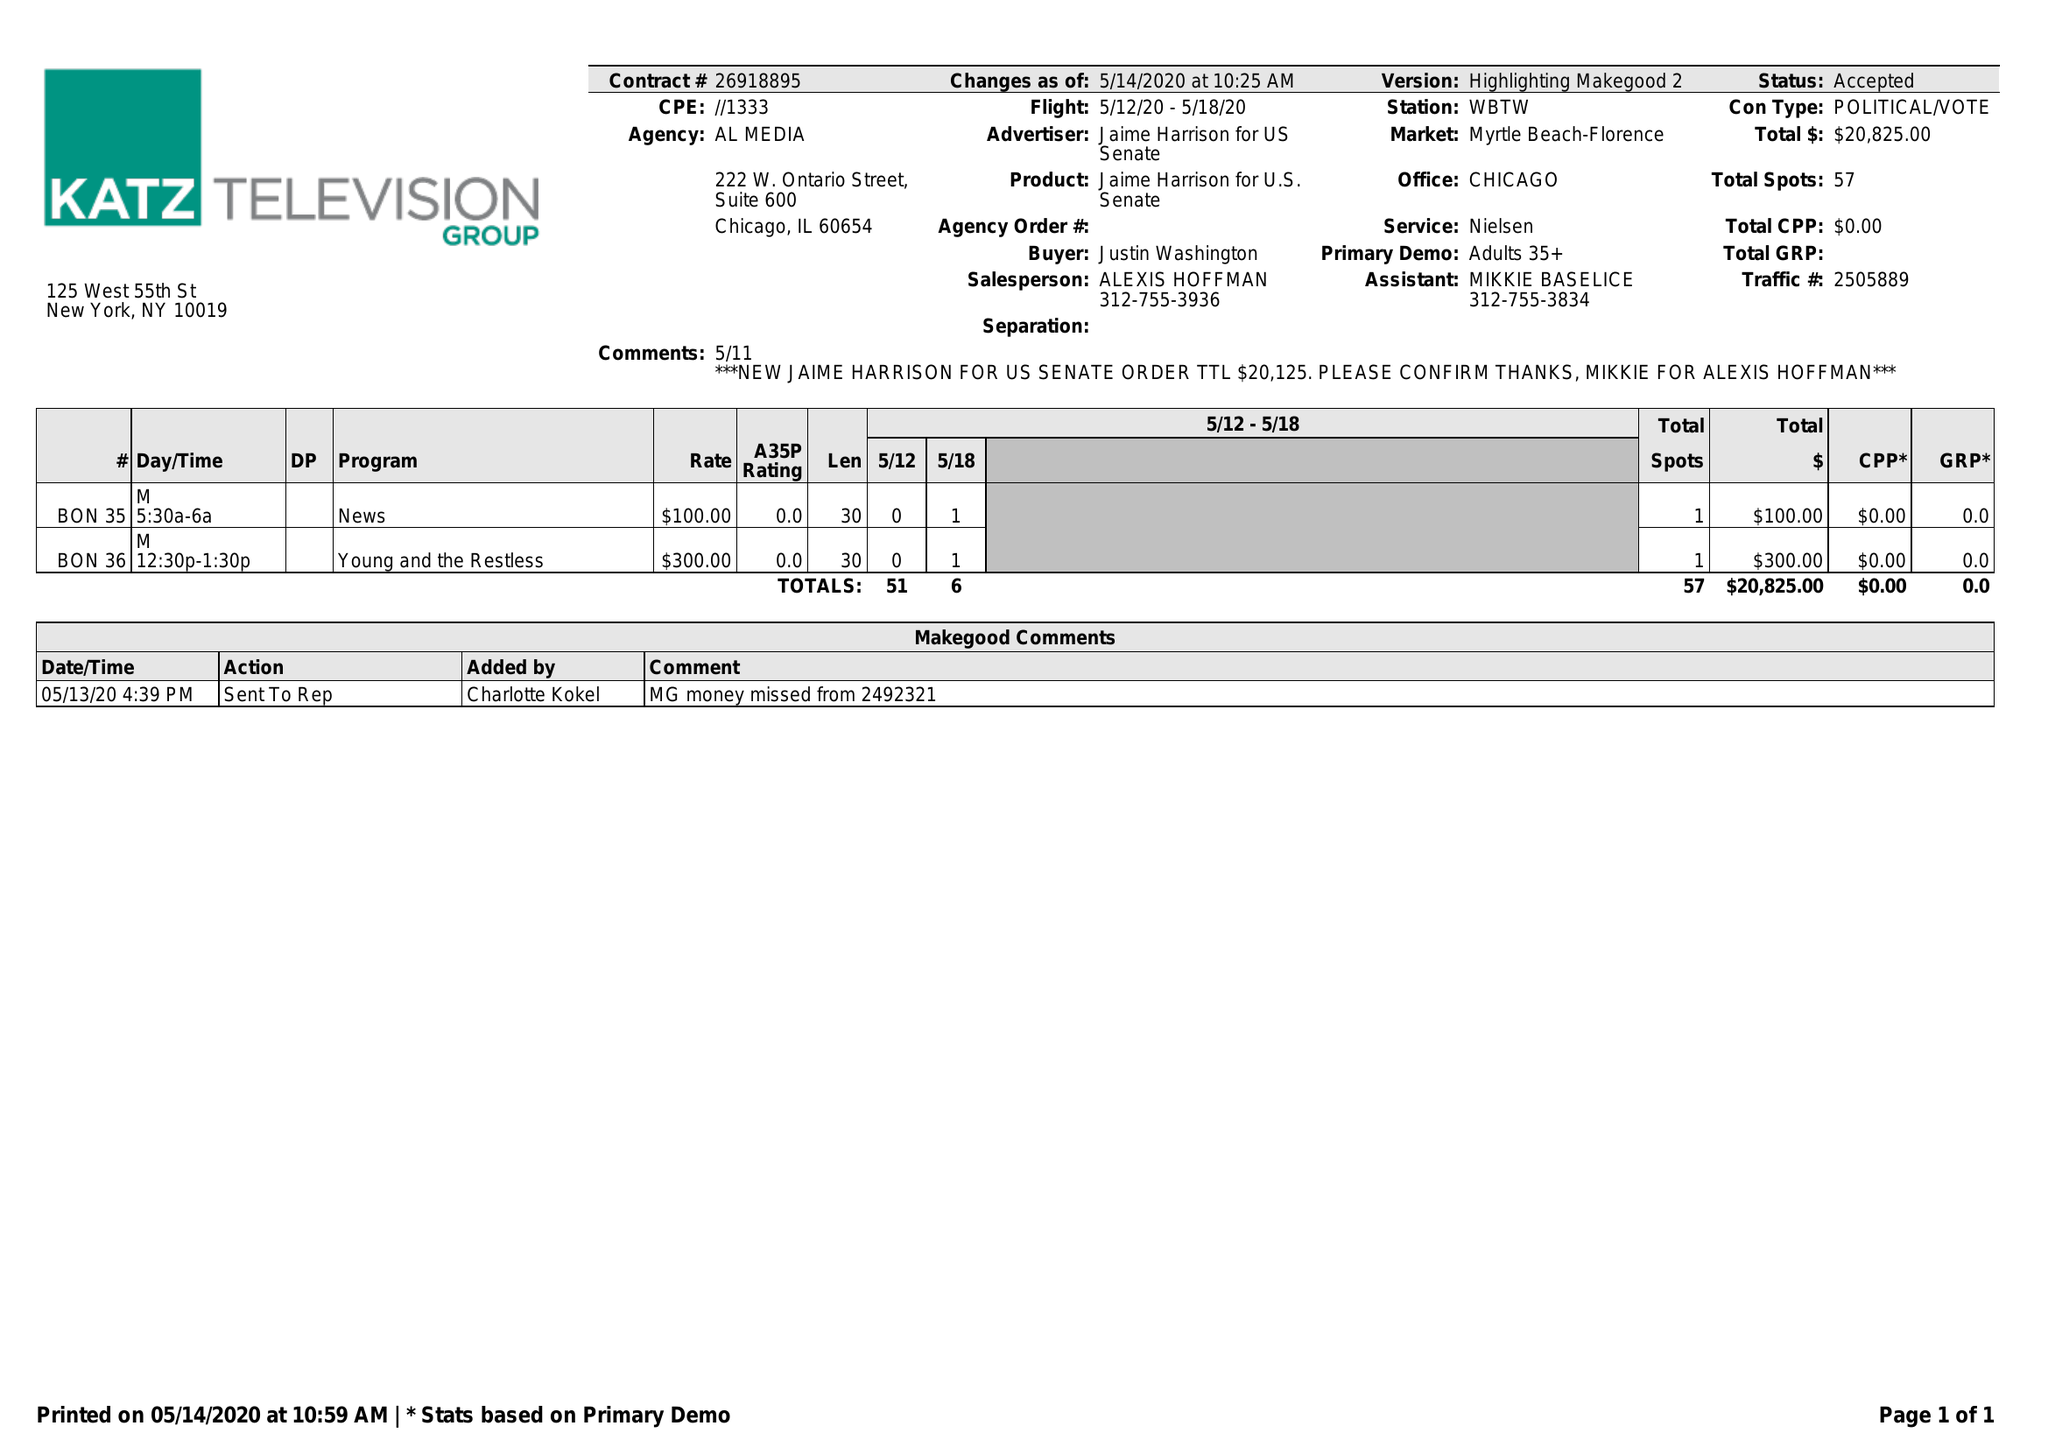What is the value for the flight_from?
Answer the question using a single word or phrase. 05/12/20 